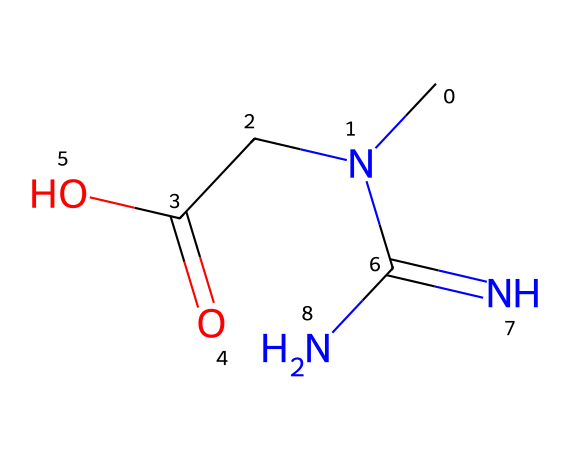What is the main functional group present in creatine? The SMILES representation indicates the presence of a carboxylic acid group (C(=O)O) due to the carbon bonded to two oxygens, one with a double bond and the other with a single bond.
Answer: carboxylic acid How many nitrogen atoms are in the structure of creatine? Analyzing the SMILES notation, there are three nitrogen atoms visible (N, N, and N), which contribute to the nitrogen content in the molecule.
Answer: three What is the molecular formula of creatine? By interpreting the SMILES representation, we can deduce that the molecule consists of carbon (C), hydrogen (H), nitrogen (N), and oxygen (O) atoms, leading to the molecular formula C4H9N3O2.
Answer: C4H9N3O2 Does creatine contain any rings in its structure? The SMILES structure can be evaluated, and it is clear that there are no ring structures present as all atoms are arranged in a linear and open chain format.
Answer: no What type of compound is creatine based on its nitrogen content? The presence of multiple nitrogen atoms, along with the functional groups in the structure, indicates that creatine is classified as an amine, particularly a type of compound known as a guanidine derivative.
Answer: amine How many total carbon atoms are present in the creatine molecule? From the SMILES notation, we observe that there are four carbon atoms as part of the molecule's structure that contribute to its carbon backbone.
Answer: four What is the type of bonding primarily observed in creatine? The structure indicates primarily covalent bonding, as it showcases shared electron pairs between atoms such as carbon, nitrogen, and oxygen throughout the molecule.
Answer: covalent 